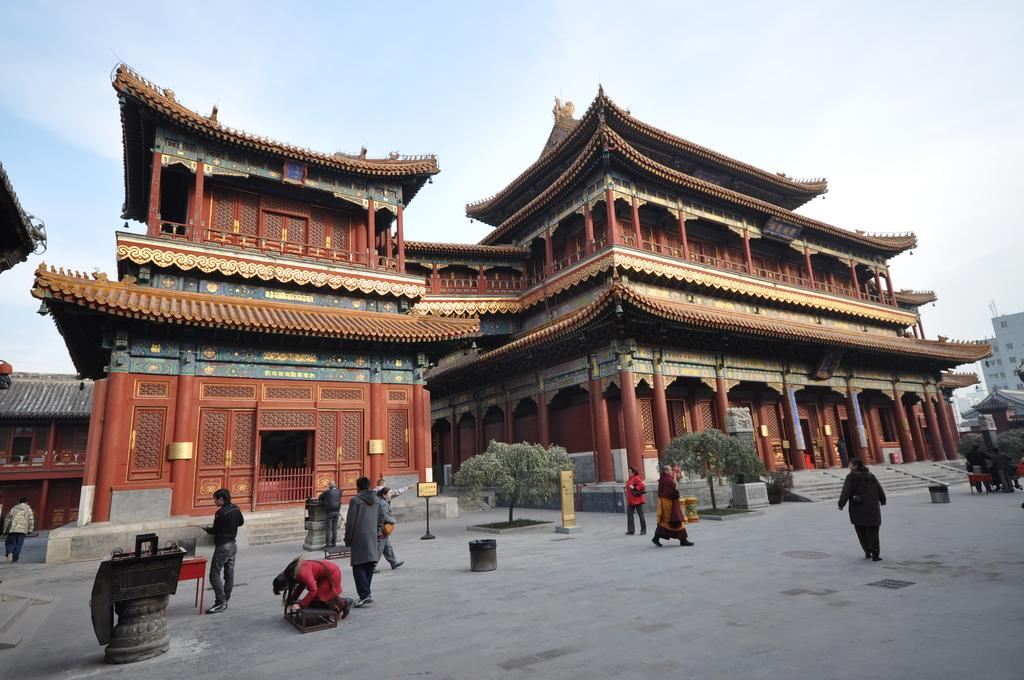How many buildings can be seen in the image? There are two buildings in the image. What else is happening in the image besides the buildings? There are people walking on the floor in the image. What type of vegetation is present in the image? There are trees in the middle of the image. What is visible at the top of the image? The sky is visible at the top of the image. What is the son doing in the scene? There is no son present in the image. How many legs can be seen on the people walking in the image? The image does not show the legs of the people walking. 